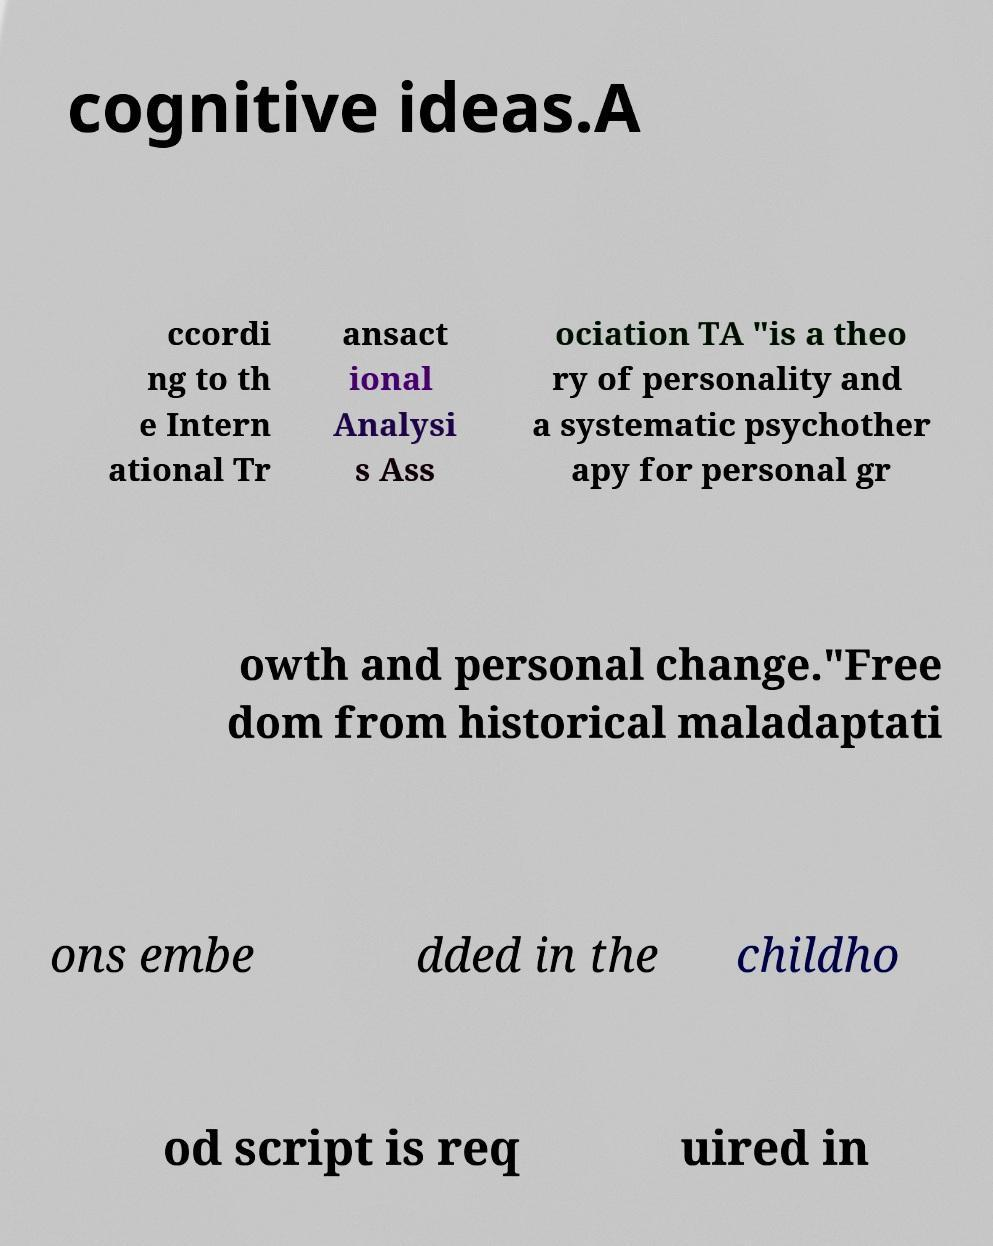Please read and relay the text visible in this image. What does it say? cognitive ideas.A ccordi ng to th e Intern ational Tr ansact ional Analysi s Ass ociation TA "is a theo ry of personality and a systematic psychother apy for personal gr owth and personal change."Free dom from historical maladaptati ons embe dded in the childho od script is req uired in 